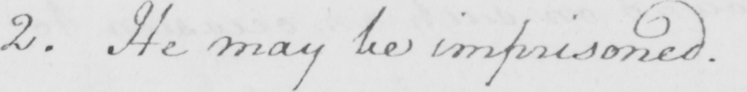Transcribe the text shown in this historical manuscript line. 2 . He may be imprisoned . 